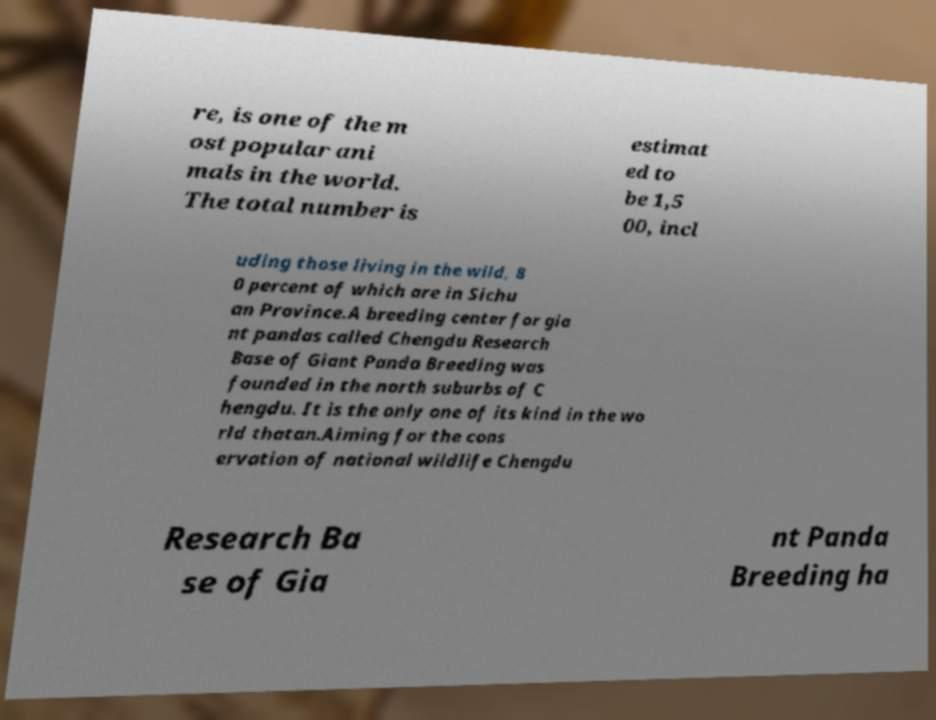Could you assist in decoding the text presented in this image and type it out clearly? re, is one of the m ost popular ani mals in the world. The total number is estimat ed to be 1,5 00, incl uding those living in the wild, 8 0 percent of which are in Sichu an Province.A breeding center for gia nt pandas called Chengdu Research Base of Giant Panda Breeding was founded in the north suburbs of C hengdu. It is the only one of its kind in the wo rld thatan.Aiming for the cons ervation of national wildlife Chengdu Research Ba se of Gia nt Panda Breeding ha 